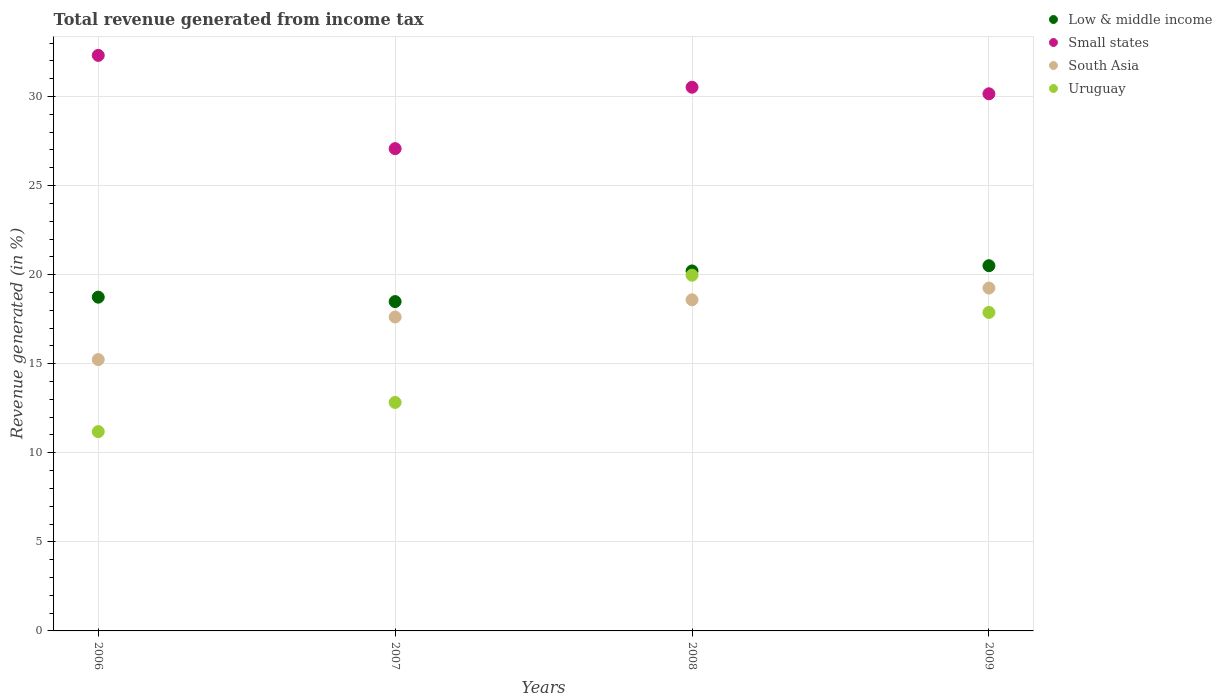What is the total revenue generated in South Asia in 2009?
Keep it short and to the point. 19.25. Across all years, what is the maximum total revenue generated in Uruguay?
Keep it short and to the point. 19.97. Across all years, what is the minimum total revenue generated in Small states?
Keep it short and to the point. 27.08. In which year was the total revenue generated in Small states minimum?
Give a very brief answer. 2007. What is the total total revenue generated in South Asia in the graph?
Offer a terse response. 70.69. What is the difference between the total revenue generated in Low & middle income in 2007 and that in 2009?
Give a very brief answer. -2.01. What is the difference between the total revenue generated in South Asia in 2007 and the total revenue generated in Uruguay in 2009?
Offer a terse response. -0.26. What is the average total revenue generated in South Asia per year?
Offer a terse response. 17.67. In the year 2008, what is the difference between the total revenue generated in Uruguay and total revenue generated in Small states?
Offer a terse response. -10.55. What is the ratio of the total revenue generated in Low & middle income in 2007 to that in 2008?
Provide a short and direct response. 0.91. Is the total revenue generated in South Asia in 2007 less than that in 2008?
Offer a terse response. Yes. What is the difference between the highest and the second highest total revenue generated in South Asia?
Your response must be concise. 0.66. What is the difference between the highest and the lowest total revenue generated in South Asia?
Ensure brevity in your answer.  4.02. In how many years, is the total revenue generated in Uruguay greater than the average total revenue generated in Uruguay taken over all years?
Keep it short and to the point. 2. Is it the case that in every year, the sum of the total revenue generated in South Asia and total revenue generated in Uruguay  is greater than the sum of total revenue generated in Small states and total revenue generated in Low & middle income?
Provide a short and direct response. No. Does the total revenue generated in Small states monotonically increase over the years?
Your response must be concise. No. How many dotlines are there?
Offer a very short reply. 4. How many years are there in the graph?
Your answer should be very brief. 4. What is the difference between two consecutive major ticks on the Y-axis?
Offer a very short reply. 5. Are the values on the major ticks of Y-axis written in scientific E-notation?
Your answer should be very brief. No. Where does the legend appear in the graph?
Your response must be concise. Top right. How many legend labels are there?
Provide a succinct answer. 4. What is the title of the graph?
Offer a terse response. Total revenue generated from income tax. What is the label or title of the Y-axis?
Your answer should be compact. Revenue generated (in %). What is the Revenue generated (in %) of Low & middle income in 2006?
Provide a succinct answer. 18.74. What is the Revenue generated (in %) in Small states in 2006?
Provide a succinct answer. 32.31. What is the Revenue generated (in %) of South Asia in 2006?
Your response must be concise. 15.23. What is the Revenue generated (in %) in Uruguay in 2006?
Make the answer very short. 11.19. What is the Revenue generated (in %) of Low & middle income in 2007?
Ensure brevity in your answer.  18.49. What is the Revenue generated (in %) in Small states in 2007?
Give a very brief answer. 27.08. What is the Revenue generated (in %) in South Asia in 2007?
Ensure brevity in your answer.  17.62. What is the Revenue generated (in %) of Uruguay in 2007?
Your answer should be compact. 12.83. What is the Revenue generated (in %) in Low & middle income in 2008?
Your answer should be very brief. 20.21. What is the Revenue generated (in %) of Small states in 2008?
Make the answer very short. 30.52. What is the Revenue generated (in %) of South Asia in 2008?
Your response must be concise. 18.59. What is the Revenue generated (in %) in Uruguay in 2008?
Keep it short and to the point. 19.97. What is the Revenue generated (in %) of Low & middle income in 2009?
Keep it short and to the point. 20.5. What is the Revenue generated (in %) of Small states in 2009?
Provide a short and direct response. 30.15. What is the Revenue generated (in %) of South Asia in 2009?
Your answer should be compact. 19.25. What is the Revenue generated (in %) in Uruguay in 2009?
Make the answer very short. 17.88. Across all years, what is the maximum Revenue generated (in %) in Low & middle income?
Provide a succinct answer. 20.5. Across all years, what is the maximum Revenue generated (in %) in Small states?
Keep it short and to the point. 32.31. Across all years, what is the maximum Revenue generated (in %) in South Asia?
Your answer should be very brief. 19.25. Across all years, what is the maximum Revenue generated (in %) in Uruguay?
Your answer should be compact. 19.97. Across all years, what is the minimum Revenue generated (in %) of Low & middle income?
Keep it short and to the point. 18.49. Across all years, what is the minimum Revenue generated (in %) of Small states?
Provide a succinct answer. 27.08. Across all years, what is the minimum Revenue generated (in %) in South Asia?
Your answer should be compact. 15.23. Across all years, what is the minimum Revenue generated (in %) of Uruguay?
Offer a very short reply. 11.19. What is the total Revenue generated (in %) of Low & middle income in the graph?
Keep it short and to the point. 77.94. What is the total Revenue generated (in %) in Small states in the graph?
Your answer should be compact. 120.06. What is the total Revenue generated (in %) of South Asia in the graph?
Ensure brevity in your answer.  70.69. What is the total Revenue generated (in %) of Uruguay in the graph?
Give a very brief answer. 61.87. What is the difference between the Revenue generated (in %) in Low & middle income in 2006 and that in 2007?
Your answer should be very brief. 0.25. What is the difference between the Revenue generated (in %) of Small states in 2006 and that in 2007?
Provide a short and direct response. 5.24. What is the difference between the Revenue generated (in %) in South Asia in 2006 and that in 2007?
Provide a succinct answer. -2.39. What is the difference between the Revenue generated (in %) in Uruguay in 2006 and that in 2007?
Your response must be concise. -1.64. What is the difference between the Revenue generated (in %) in Low & middle income in 2006 and that in 2008?
Give a very brief answer. -1.47. What is the difference between the Revenue generated (in %) in Small states in 2006 and that in 2008?
Ensure brevity in your answer.  1.79. What is the difference between the Revenue generated (in %) in South Asia in 2006 and that in 2008?
Offer a very short reply. -3.36. What is the difference between the Revenue generated (in %) of Uruguay in 2006 and that in 2008?
Give a very brief answer. -8.78. What is the difference between the Revenue generated (in %) of Low & middle income in 2006 and that in 2009?
Make the answer very short. -1.77. What is the difference between the Revenue generated (in %) of Small states in 2006 and that in 2009?
Provide a short and direct response. 2.16. What is the difference between the Revenue generated (in %) in South Asia in 2006 and that in 2009?
Make the answer very short. -4.02. What is the difference between the Revenue generated (in %) in Uruguay in 2006 and that in 2009?
Offer a very short reply. -6.69. What is the difference between the Revenue generated (in %) in Low & middle income in 2007 and that in 2008?
Give a very brief answer. -1.72. What is the difference between the Revenue generated (in %) in Small states in 2007 and that in 2008?
Give a very brief answer. -3.45. What is the difference between the Revenue generated (in %) of South Asia in 2007 and that in 2008?
Give a very brief answer. -0.96. What is the difference between the Revenue generated (in %) in Uruguay in 2007 and that in 2008?
Ensure brevity in your answer.  -7.14. What is the difference between the Revenue generated (in %) in Low & middle income in 2007 and that in 2009?
Provide a short and direct response. -2.02. What is the difference between the Revenue generated (in %) of Small states in 2007 and that in 2009?
Give a very brief answer. -3.08. What is the difference between the Revenue generated (in %) in South Asia in 2007 and that in 2009?
Give a very brief answer. -1.62. What is the difference between the Revenue generated (in %) of Uruguay in 2007 and that in 2009?
Your answer should be compact. -5.05. What is the difference between the Revenue generated (in %) in Low & middle income in 2008 and that in 2009?
Your answer should be very brief. -0.29. What is the difference between the Revenue generated (in %) of Small states in 2008 and that in 2009?
Your response must be concise. 0.37. What is the difference between the Revenue generated (in %) of South Asia in 2008 and that in 2009?
Ensure brevity in your answer.  -0.66. What is the difference between the Revenue generated (in %) of Uruguay in 2008 and that in 2009?
Your answer should be compact. 2.09. What is the difference between the Revenue generated (in %) of Low & middle income in 2006 and the Revenue generated (in %) of Small states in 2007?
Keep it short and to the point. -8.34. What is the difference between the Revenue generated (in %) of Low & middle income in 2006 and the Revenue generated (in %) of South Asia in 2007?
Offer a very short reply. 1.11. What is the difference between the Revenue generated (in %) in Low & middle income in 2006 and the Revenue generated (in %) in Uruguay in 2007?
Your answer should be very brief. 5.91. What is the difference between the Revenue generated (in %) of Small states in 2006 and the Revenue generated (in %) of South Asia in 2007?
Give a very brief answer. 14.69. What is the difference between the Revenue generated (in %) of Small states in 2006 and the Revenue generated (in %) of Uruguay in 2007?
Ensure brevity in your answer.  19.48. What is the difference between the Revenue generated (in %) in South Asia in 2006 and the Revenue generated (in %) in Uruguay in 2007?
Provide a short and direct response. 2.41. What is the difference between the Revenue generated (in %) of Low & middle income in 2006 and the Revenue generated (in %) of Small states in 2008?
Make the answer very short. -11.79. What is the difference between the Revenue generated (in %) in Low & middle income in 2006 and the Revenue generated (in %) in South Asia in 2008?
Provide a succinct answer. 0.15. What is the difference between the Revenue generated (in %) of Low & middle income in 2006 and the Revenue generated (in %) of Uruguay in 2008?
Your response must be concise. -1.23. What is the difference between the Revenue generated (in %) in Small states in 2006 and the Revenue generated (in %) in South Asia in 2008?
Your answer should be very brief. 13.72. What is the difference between the Revenue generated (in %) of Small states in 2006 and the Revenue generated (in %) of Uruguay in 2008?
Offer a terse response. 12.34. What is the difference between the Revenue generated (in %) in South Asia in 2006 and the Revenue generated (in %) in Uruguay in 2008?
Your answer should be very brief. -4.74. What is the difference between the Revenue generated (in %) of Low & middle income in 2006 and the Revenue generated (in %) of Small states in 2009?
Your answer should be compact. -11.42. What is the difference between the Revenue generated (in %) of Low & middle income in 2006 and the Revenue generated (in %) of South Asia in 2009?
Make the answer very short. -0.51. What is the difference between the Revenue generated (in %) in Low & middle income in 2006 and the Revenue generated (in %) in Uruguay in 2009?
Give a very brief answer. 0.86. What is the difference between the Revenue generated (in %) of Small states in 2006 and the Revenue generated (in %) of South Asia in 2009?
Ensure brevity in your answer.  13.06. What is the difference between the Revenue generated (in %) in Small states in 2006 and the Revenue generated (in %) in Uruguay in 2009?
Offer a terse response. 14.43. What is the difference between the Revenue generated (in %) in South Asia in 2006 and the Revenue generated (in %) in Uruguay in 2009?
Provide a succinct answer. -2.65. What is the difference between the Revenue generated (in %) of Low & middle income in 2007 and the Revenue generated (in %) of Small states in 2008?
Ensure brevity in your answer.  -12.03. What is the difference between the Revenue generated (in %) of Low & middle income in 2007 and the Revenue generated (in %) of Uruguay in 2008?
Provide a succinct answer. -1.48. What is the difference between the Revenue generated (in %) in Small states in 2007 and the Revenue generated (in %) in South Asia in 2008?
Provide a succinct answer. 8.49. What is the difference between the Revenue generated (in %) of Small states in 2007 and the Revenue generated (in %) of Uruguay in 2008?
Give a very brief answer. 7.1. What is the difference between the Revenue generated (in %) of South Asia in 2007 and the Revenue generated (in %) of Uruguay in 2008?
Offer a very short reply. -2.35. What is the difference between the Revenue generated (in %) of Low & middle income in 2007 and the Revenue generated (in %) of Small states in 2009?
Ensure brevity in your answer.  -11.67. What is the difference between the Revenue generated (in %) in Low & middle income in 2007 and the Revenue generated (in %) in South Asia in 2009?
Make the answer very short. -0.76. What is the difference between the Revenue generated (in %) in Low & middle income in 2007 and the Revenue generated (in %) in Uruguay in 2009?
Provide a succinct answer. 0.61. What is the difference between the Revenue generated (in %) in Small states in 2007 and the Revenue generated (in %) in South Asia in 2009?
Give a very brief answer. 7.83. What is the difference between the Revenue generated (in %) of Small states in 2007 and the Revenue generated (in %) of Uruguay in 2009?
Provide a short and direct response. 9.2. What is the difference between the Revenue generated (in %) of South Asia in 2007 and the Revenue generated (in %) of Uruguay in 2009?
Offer a terse response. -0.26. What is the difference between the Revenue generated (in %) in Low & middle income in 2008 and the Revenue generated (in %) in Small states in 2009?
Your answer should be very brief. -9.94. What is the difference between the Revenue generated (in %) in Low & middle income in 2008 and the Revenue generated (in %) in South Asia in 2009?
Your answer should be very brief. 0.96. What is the difference between the Revenue generated (in %) in Low & middle income in 2008 and the Revenue generated (in %) in Uruguay in 2009?
Your answer should be very brief. 2.33. What is the difference between the Revenue generated (in %) of Small states in 2008 and the Revenue generated (in %) of South Asia in 2009?
Ensure brevity in your answer.  11.27. What is the difference between the Revenue generated (in %) in Small states in 2008 and the Revenue generated (in %) in Uruguay in 2009?
Ensure brevity in your answer.  12.64. What is the difference between the Revenue generated (in %) in South Asia in 2008 and the Revenue generated (in %) in Uruguay in 2009?
Keep it short and to the point. 0.71. What is the average Revenue generated (in %) of Low & middle income per year?
Your answer should be very brief. 19.48. What is the average Revenue generated (in %) of Small states per year?
Offer a terse response. 30.02. What is the average Revenue generated (in %) in South Asia per year?
Offer a terse response. 17.67. What is the average Revenue generated (in %) in Uruguay per year?
Your answer should be very brief. 15.47. In the year 2006, what is the difference between the Revenue generated (in %) in Low & middle income and Revenue generated (in %) in Small states?
Offer a very short reply. -13.57. In the year 2006, what is the difference between the Revenue generated (in %) in Low & middle income and Revenue generated (in %) in South Asia?
Your response must be concise. 3.5. In the year 2006, what is the difference between the Revenue generated (in %) in Low & middle income and Revenue generated (in %) in Uruguay?
Give a very brief answer. 7.55. In the year 2006, what is the difference between the Revenue generated (in %) in Small states and Revenue generated (in %) in South Asia?
Offer a very short reply. 17.08. In the year 2006, what is the difference between the Revenue generated (in %) of Small states and Revenue generated (in %) of Uruguay?
Your answer should be compact. 21.12. In the year 2006, what is the difference between the Revenue generated (in %) in South Asia and Revenue generated (in %) in Uruguay?
Offer a terse response. 4.04. In the year 2007, what is the difference between the Revenue generated (in %) in Low & middle income and Revenue generated (in %) in Small states?
Offer a terse response. -8.59. In the year 2007, what is the difference between the Revenue generated (in %) in Low & middle income and Revenue generated (in %) in South Asia?
Your response must be concise. 0.86. In the year 2007, what is the difference between the Revenue generated (in %) in Low & middle income and Revenue generated (in %) in Uruguay?
Offer a very short reply. 5.66. In the year 2007, what is the difference between the Revenue generated (in %) of Small states and Revenue generated (in %) of South Asia?
Your response must be concise. 9.45. In the year 2007, what is the difference between the Revenue generated (in %) of Small states and Revenue generated (in %) of Uruguay?
Provide a succinct answer. 14.25. In the year 2007, what is the difference between the Revenue generated (in %) in South Asia and Revenue generated (in %) in Uruguay?
Your answer should be very brief. 4.8. In the year 2008, what is the difference between the Revenue generated (in %) of Low & middle income and Revenue generated (in %) of Small states?
Provide a succinct answer. -10.31. In the year 2008, what is the difference between the Revenue generated (in %) of Low & middle income and Revenue generated (in %) of South Asia?
Your answer should be compact. 1.62. In the year 2008, what is the difference between the Revenue generated (in %) of Low & middle income and Revenue generated (in %) of Uruguay?
Provide a succinct answer. 0.24. In the year 2008, what is the difference between the Revenue generated (in %) of Small states and Revenue generated (in %) of South Asia?
Provide a short and direct response. 11.93. In the year 2008, what is the difference between the Revenue generated (in %) in Small states and Revenue generated (in %) in Uruguay?
Provide a short and direct response. 10.55. In the year 2008, what is the difference between the Revenue generated (in %) in South Asia and Revenue generated (in %) in Uruguay?
Offer a very short reply. -1.38. In the year 2009, what is the difference between the Revenue generated (in %) of Low & middle income and Revenue generated (in %) of Small states?
Ensure brevity in your answer.  -9.65. In the year 2009, what is the difference between the Revenue generated (in %) of Low & middle income and Revenue generated (in %) of South Asia?
Ensure brevity in your answer.  1.26. In the year 2009, what is the difference between the Revenue generated (in %) in Low & middle income and Revenue generated (in %) in Uruguay?
Your answer should be very brief. 2.62. In the year 2009, what is the difference between the Revenue generated (in %) of Small states and Revenue generated (in %) of South Asia?
Your answer should be compact. 10.91. In the year 2009, what is the difference between the Revenue generated (in %) in Small states and Revenue generated (in %) in Uruguay?
Keep it short and to the point. 12.28. In the year 2009, what is the difference between the Revenue generated (in %) in South Asia and Revenue generated (in %) in Uruguay?
Your answer should be very brief. 1.37. What is the ratio of the Revenue generated (in %) in Low & middle income in 2006 to that in 2007?
Offer a terse response. 1.01. What is the ratio of the Revenue generated (in %) of Small states in 2006 to that in 2007?
Provide a succinct answer. 1.19. What is the ratio of the Revenue generated (in %) in South Asia in 2006 to that in 2007?
Your answer should be compact. 0.86. What is the ratio of the Revenue generated (in %) in Uruguay in 2006 to that in 2007?
Provide a short and direct response. 0.87. What is the ratio of the Revenue generated (in %) of Low & middle income in 2006 to that in 2008?
Offer a very short reply. 0.93. What is the ratio of the Revenue generated (in %) of Small states in 2006 to that in 2008?
Make the answer very short. 1.06. What is the ratio of the Revenue generated (in %) of South Asia in 2006 to that in 2008?
Make the answer very short. 0.82. What is the ratio of the Revenue generated (in %) of Uruguay in 2006 to that in 2008?
Make the answer very short. 0.56. What is the ratio of the Revenue generated (in %) of Low & middle income in 2006 to that in 2009?
Your answer should be very brief. 0.91. What is the ratio of the Revenue generated (in %) of Small states in 2006 to that in 2009?
Give a very brief answer. 1.07. What is the ratio of the Revenue generated (in %) of South Asia in 2006 to that in 2009?
Keep it short and to the point. 0.79. What is the ratio of the Revenue generated (in %) in Uruguay in 2006 to that in 2009?
Provide a succinct answer. 0.63. What is the ratio of the Revenue generated (in %) in Low & middle income in 2007 to that in 2008?
Keep it short and to the point. 0.91. What is the ratio of the Revenue generated (in %) in Small states in 2007 to that in 2008?
Provide a short and direct response. 0.89. What is the ratio of the Revenue generated (in %) in South Asia in 2007 to that in 2008?
Offer a very short reply. 0.95. What is the ratio of the Revenue generated (in %) of Uruguay in 2007 to that in 2008?
Offer a very short reply. 0.64. What is the ratio of the Revenue generated (in %) in Low & middle income in 2007 to that in 2009?
Give a very brief answer. 0.9. What is the ratio of the Revenue generated (in %) of Small states in 2007 to that in 2009?
Offer a very short reply. 0.9. What is the ratio of the Revenue generated (in %) in South Asia in 2007 to that in 2009?
Offer a very short reply. 0.92. What is the ratio of the Revenue generated (in %) of Uruguay in 2007 to that in 2009?
Your response must be concise. 0.72. What is the ratio of the Revenue generated (in %) of Low & middle income in 2008 to that in 2009?
Give a very brief answer. 0.99. What is the ratio of the Revenue generated (in %) of Small states in 2008 to that in 2009?
Keep it short and to the point. 1.01. What is the ratio of the Revenue generated (in %) of South Asia in 2008 to that in 2009?
Give a very brief answer. 0.97. What is the ratio of the Revenue generated (in %) of Uruguay in 2008 to that in 2009?
Your answer should be compact. 1.12. What is the difference between the highest and the second highest Revenue generated (in %) of Low & middle income?
Offer a terse response. 0.29. What is the difference between the highest and the second highest Revenue generated (in %) in Small states?
Keep it short and to the point. 1.79. What is the difference between the highest and the second highest Revenue generated (in %) in South Asia?
Provide a short and direct response. 0.66. What is the difference between the highest and the second highest Revenue generated (in %) of Uruguay?
Keep it short and to the point. 2.09. What is the difference between the highest and the lowest Revenue generated (in %) in Low & middle income?
Make the answer very short. 2.02. What is the difference between the highest and the lowest Revenue generated (in %) of Small states?
Keep it short and to the point. 5.24. What is the difference between the highest and the lowest Revenue generated (in %) of South Asia?
Offer a terse response. 4.02. What is the difference between the highest and the lowest Revenue generated (in %) of Uruguay?
Keep it short and to the point. 8.78. 